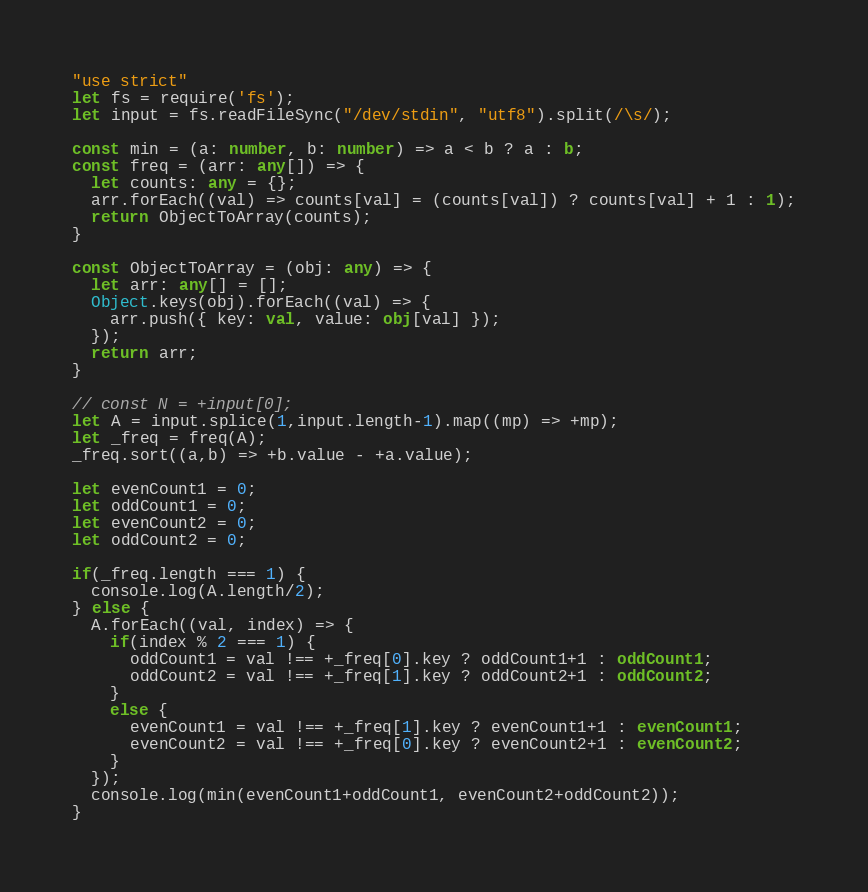Convert code to text. <code><loc_0><loc_0><loc_500><loc_500><_TypeScript_>"use strict"
let fs = require('fs');
let input = fs.readFileSync("/dev/stdin", "utf8").split(/\s/);

const min = (a: number, b: number) => a < b ? a : b;
const freq = (arr: any[]) => {
  let counts: any = {};
  arr.forEach((val) => counts[val] = (counts[val]) ? counts[val] + 1 : 1);
  return ObjectToArray(counts);
}

const ObjectToArray = (obj: any) => {
  let arr: any[] = [];
  Object.keys(obj).forEach((val) => {
    arr.push({ key: val, value: obj[val] });
  });
  return arr;
}

// const N = +input[0];
let A = input.splice(1,input.length-1).map((mp) => +mp);
let _freq = freq(A);
_freq.sort((a,b) => +b.value - +a.value);

let evenCount1 = 0;
let oddCount1 = 0;
let evenCount2 = 0;
let oddCount2 = 0;

if(_freq.length === 1) {
  console.log(A.length/2);
} else {
  A.forEach((val, index) => {
    if(index % 2 === 1) {
      oddCount1 = val !== +_freq[0].key ? oddCount1+1 : oddCount1;
      oddCount2 = val !== +_freq[1].key ? oddCount2+1 : oddCount2;
    }
    else {
      evenCount1 = val !== +_freq[1].key ? evenCount1+1 : evenCount1;
      evenCount2 = val !== +_freq[0].key ? evenCount2+1 : evenCount2;
    }
  });
  console.log(min(evenCount1+oddCount1, evenCount2+oddCount2));
}
</code> 